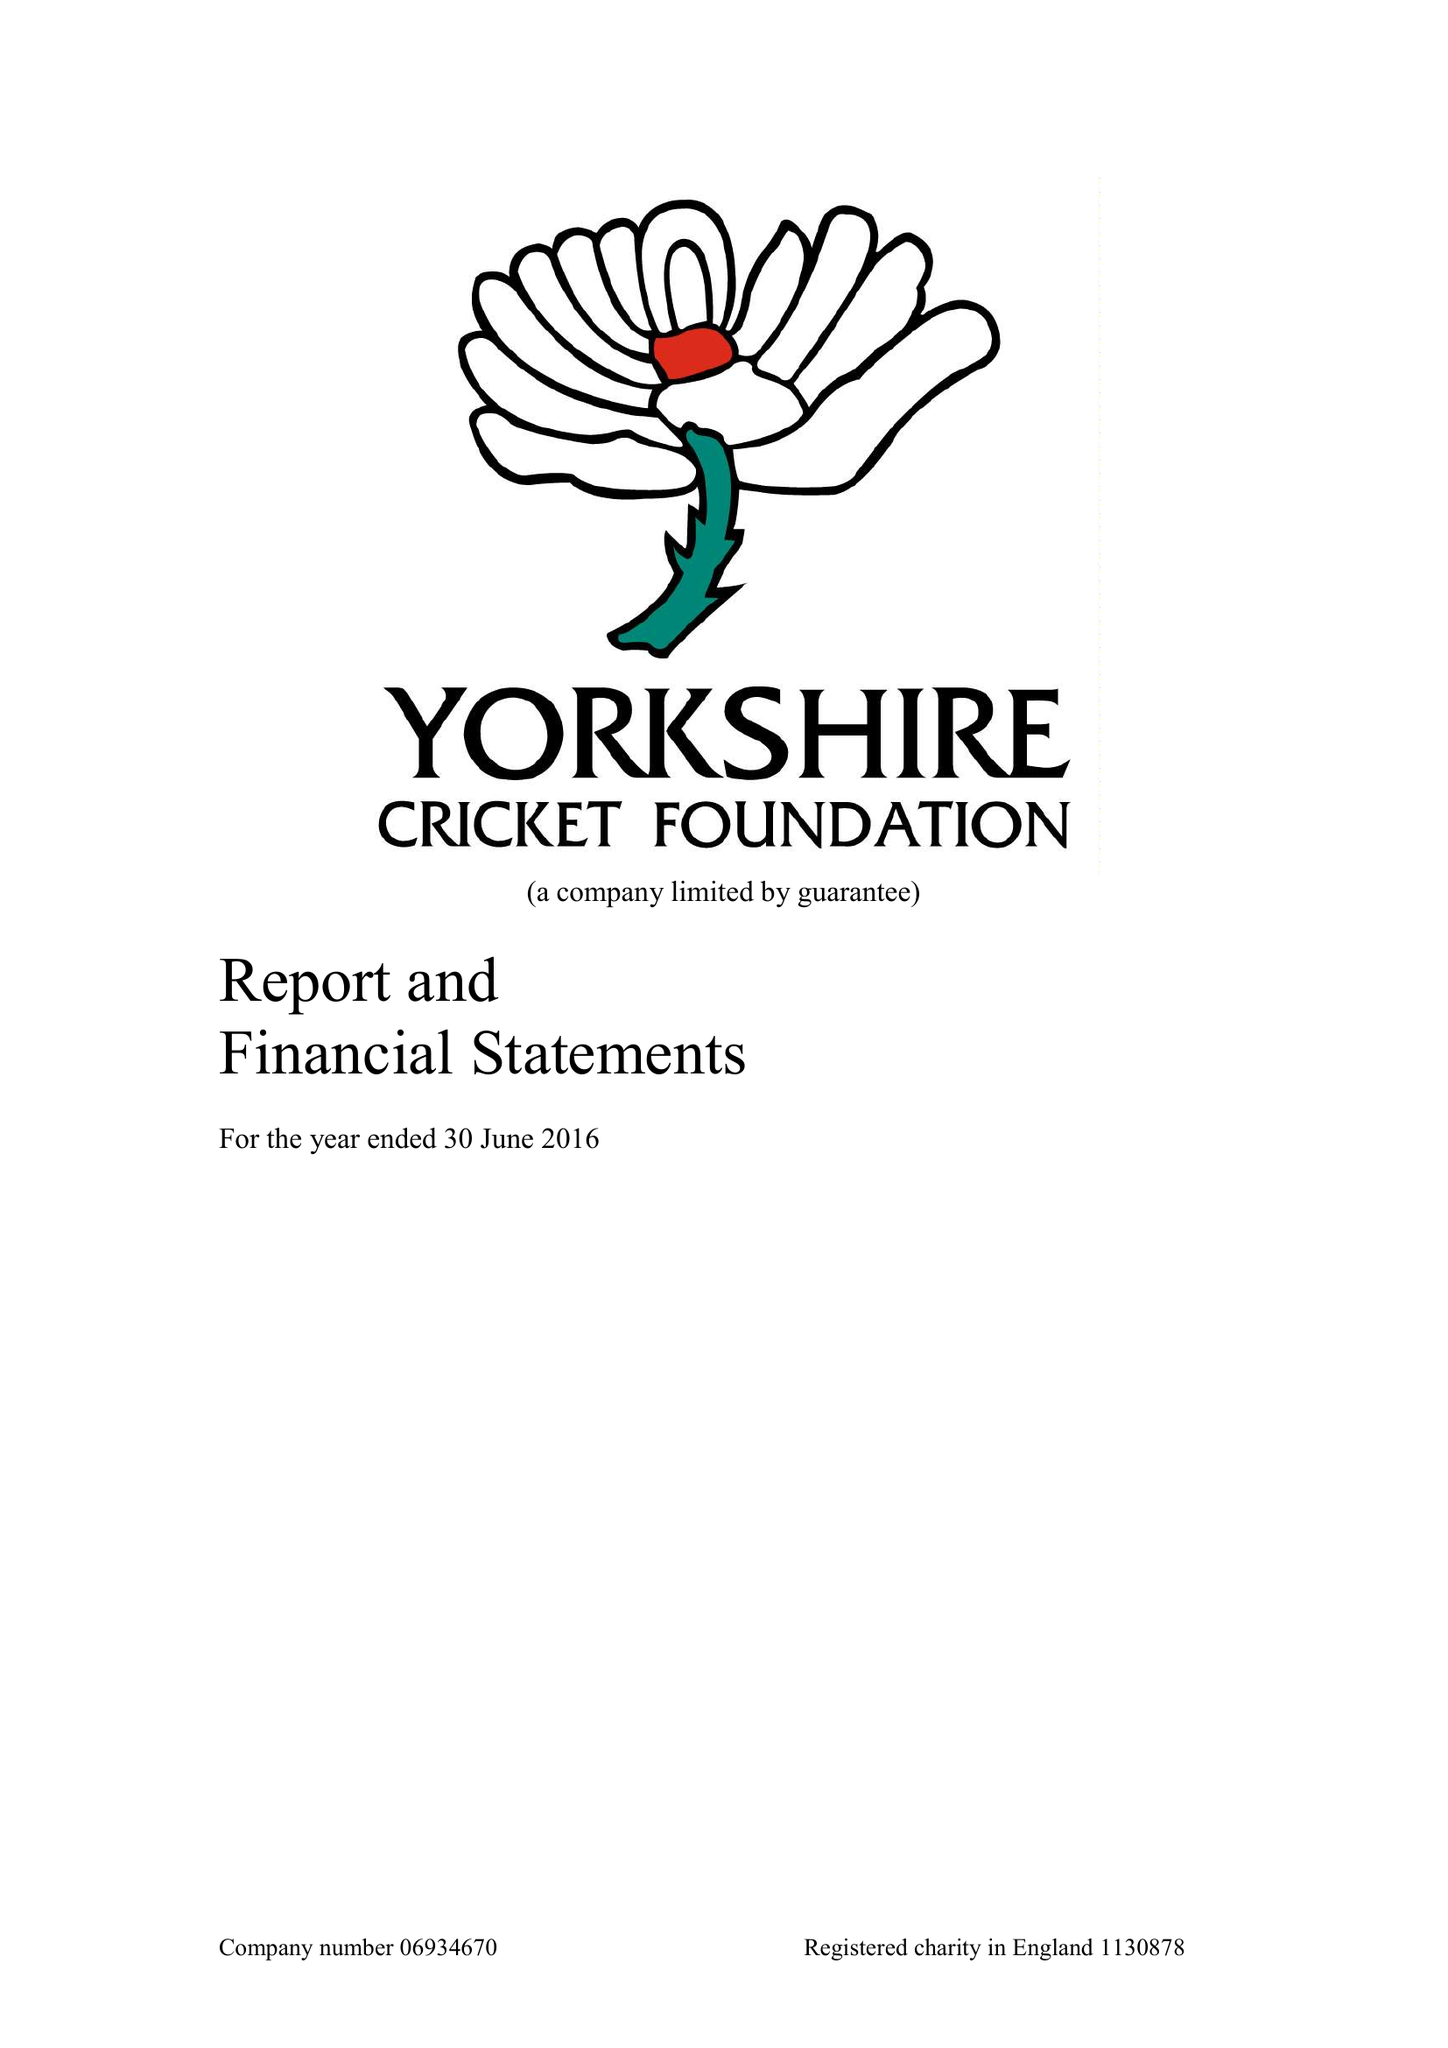What is the value for the charity_name?
Answer the question using a single word or phrase. The Yorkshire Cricket Foundation 